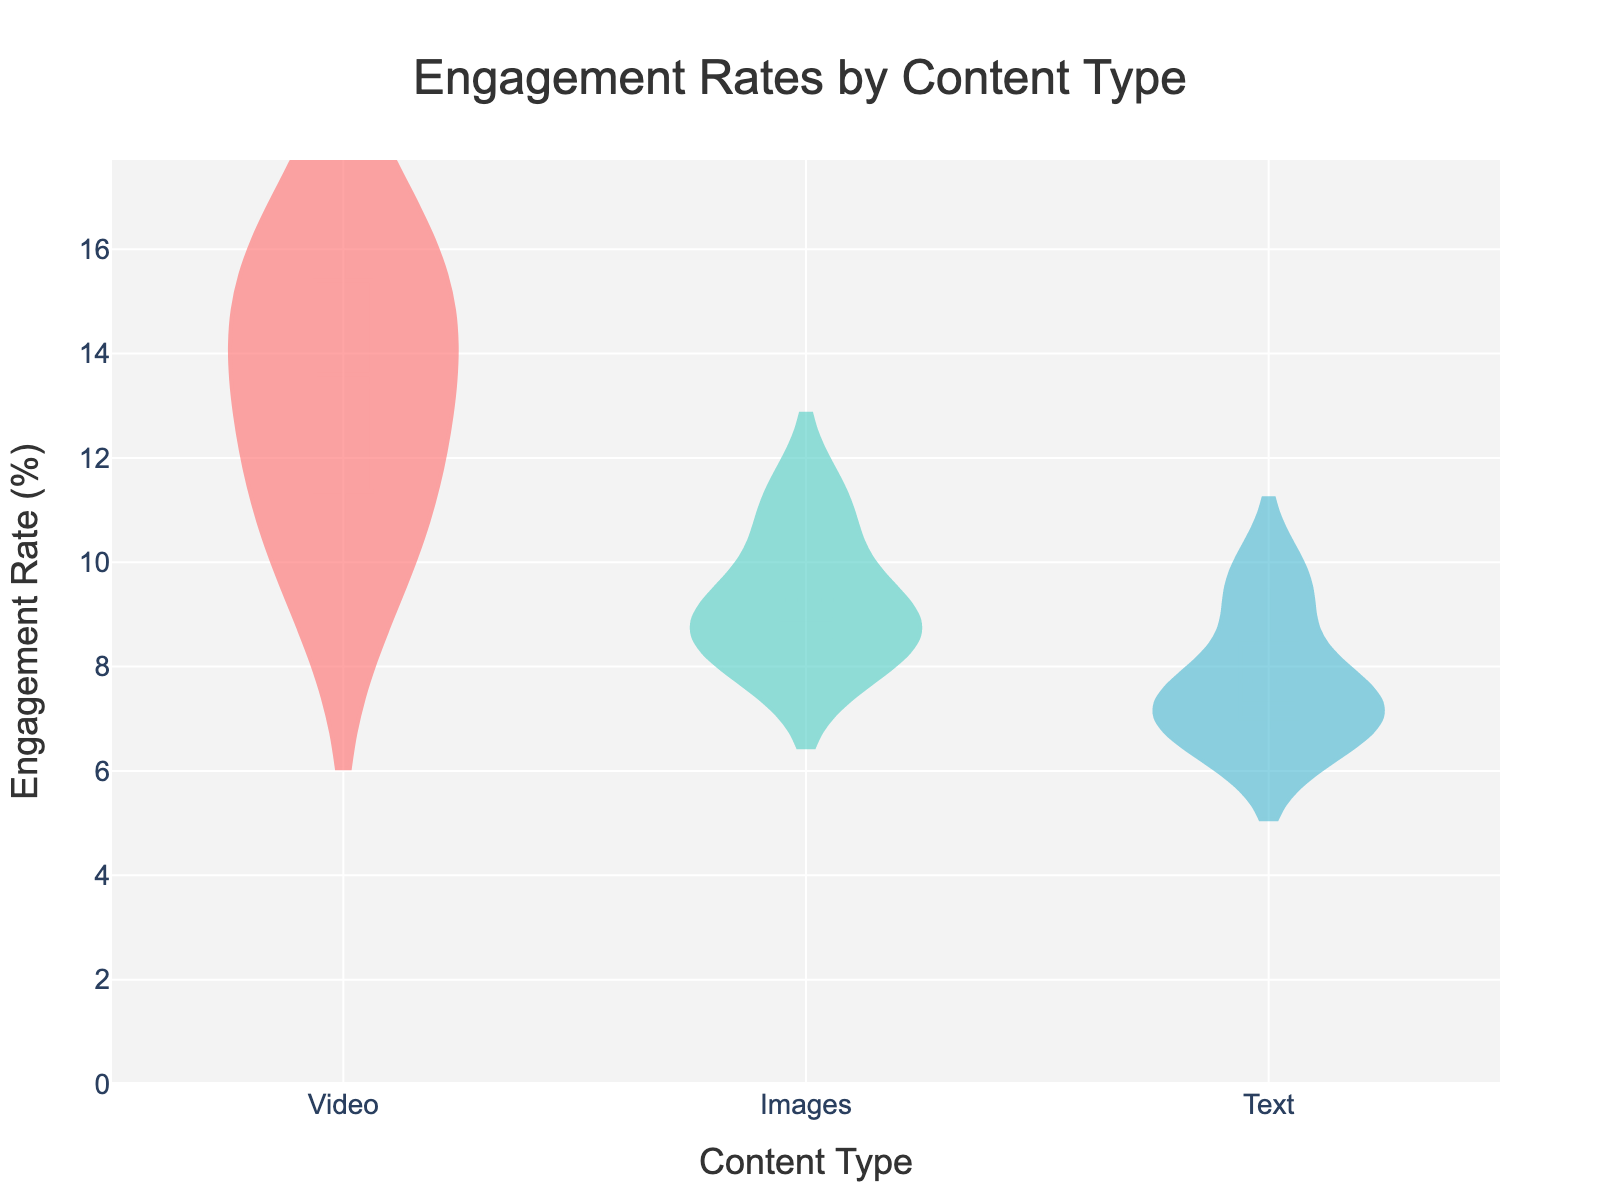What are the types of content displayed in the figure? The figure contains three types of content: Video, Images, and Text. This information can be inferred from the x-axis labels provided for the violin plots.
Answer: Video, Images, Text What is the title of the figure? The title of the figure is displayed at the top and reads "Engagement Rates by Content Type."
Answer: Engagement Rates by Content Type What is the range of the y-axis? The y-axis range can be observed from the axis labels, and it spans from 0% to a slightly above the highest engagement rate recorded, which is around 17.7%.
Answer: 0 to 17.7% Which content type has the highest engagement rate? By observing the tops of the violin plots, we can see that the Video content type has the highest engagement rate of about 16.1%.
Answer: Video What is the mean engagement rate for the Images content type? The mean engagement rate is represented by the horizontal line within the box in the violin plot for each content type. For Images, this line is around 9.3%.
Answer: 9.3% Which content type shows the smallest interquartile range (IQR)? The interquartile range (IQR) is indicated by the width of the boxes within the violin plots. Images content type has the smallest width, indicating the smallest IQR.
Answer: Images What is the median engagement rate for the Text content type? The median engagement rate corresponds to the central point within the box in the violin plot. For Text, it appears to be around 7.35%.
Answer: 7.35% By how much does the highest engagement rate for Video content exceed the highest engagement rate for Text content? The highest engagement rate for Video is about 16.1%, and for Text, it is around 9.5%. The difference is 16.1% - 9.5% = 6.6%.
Answer: 6.6% Which content type has the most spread in engagement rates? The spread of engagement rates is indicated by the length of the entire violin plot, including the tails. Video has the most spread as it covers engagement rates from around 10.2% to 16.1%.
Answer: Video Which content type has the lowest minimum engagement rate? The minimum engagement rate can be observed from the bottom of the violin plots. Text has the lowest minimum engagement rate, which is around 6.8%.
Answer: Text 